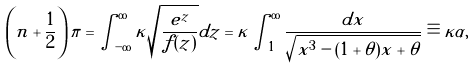Convert formula to latex. <formula><loc_0><loc_0><loc_500><loc_500>\left ( n + \frac { 1 } { 2 } \right ) \pi = \int _ { - \infty } ^ { \infty } \kappa \sqrt { \frac { e ^ { z } } { f ( z ) } } d z = \kappa \int _ { 1 } ^ { \infty } \frac { d x } { \sqrt { x ^ { 3 } - ( 1 + \theta ) x + \theta } } \equiv \kappa \alpha ,</formula> 